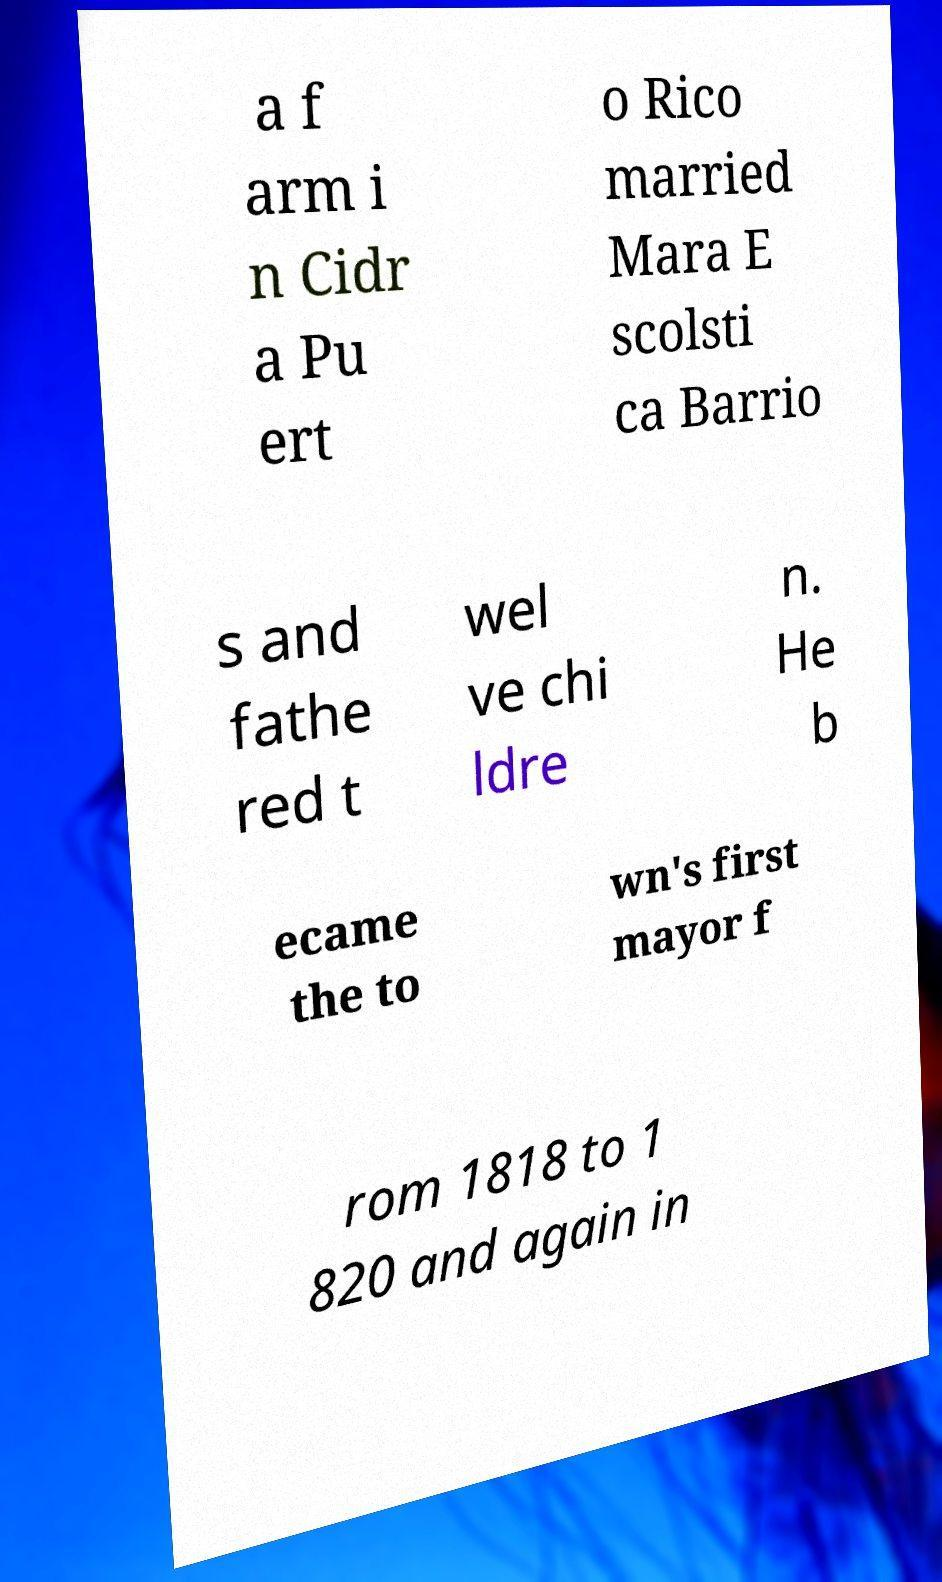Please identify and transcribe the text found in this image. a f arm i n Cidr a Pu ert o Rico married Mara E scolsti ca Barrio s and fathe red t wel ve chi ldre n. He b ecame the to wn's first mayor f rom 1818 to 1 820 and again in 